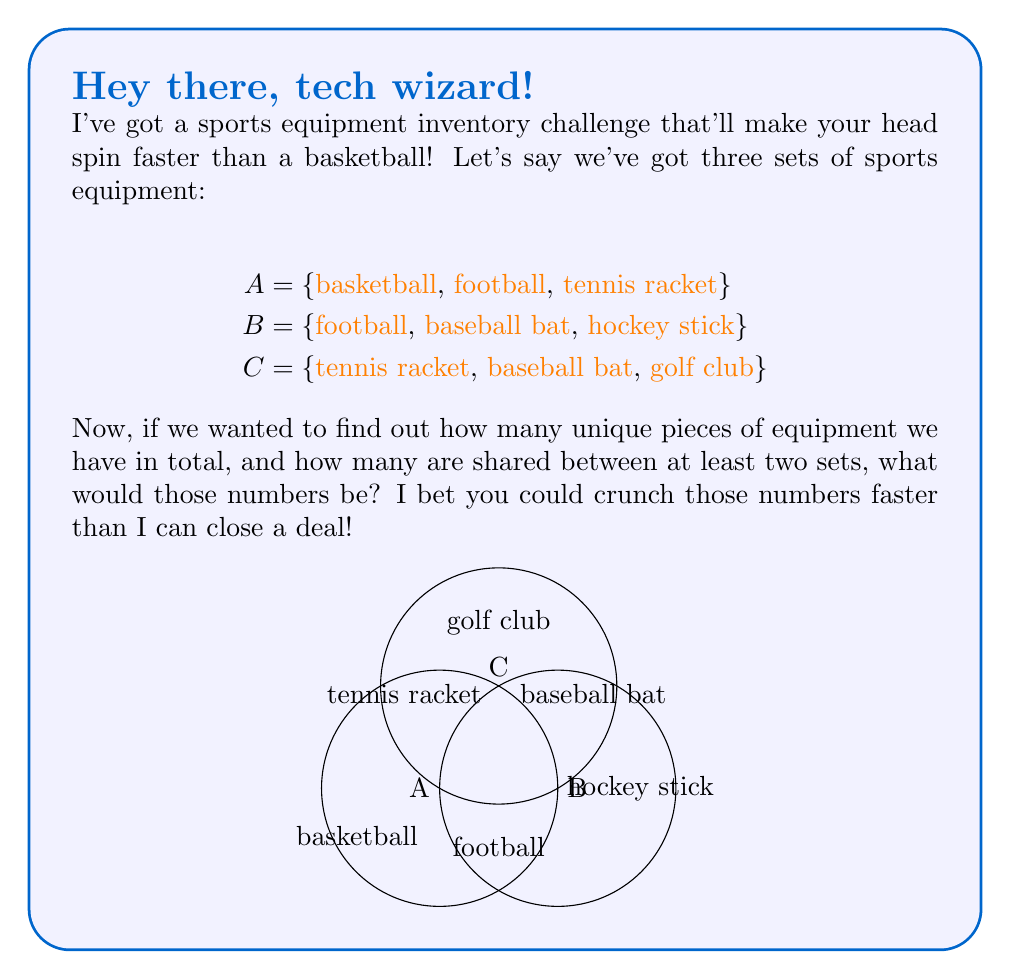Solve this math problem. Let's approach this step-by-step using set theory:

1) First, we need to find the union of all three sets to determine the total number of unique pieces of equipment:

   $$A \cup B \cup C = \{\text{basketball, football, tennis racket, baseball bat, hockey stick, golf club}\}$$

2) To count the elements in this union, we use the cardinality notation:

   $$|A \cup B \cup C| = 6$$

3) Now, to find how many items are shared between at least two sets, we need to find the elements in the intersections:

   $$A \cap B = \{\text{football}\}$$
   $$A \cap C = \{\text{tennis racket}\}$$
   $$B \cap C = \{\text{baseball bat}\}$$

4) The union of these intersections gives us all items shared by at least two sets:

   $$(A \cap B) \cup (A \cap C) \cup (B \cap C) = \{\text{football, tennis racket, baseball bat}\}$$

5) The cardinality of this set is:

   $$|(A \cap B) \cup (A \cap C) \cup (B \cap C)| = 3$$

Therefore, there are 6 unique pieces of equipment in total, and 3 pieces are shared between at least two sets.
Answer: 6 and 3 